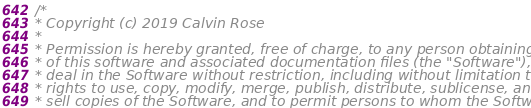<code> <loc_0><loc_0><loc_500><loc_500><_C_>/*
* Copyright (c) 2019 Calvin Rose
*
* Permission is hereby granted, free of charge, to any person obtaining a copy
* of this software and associated documentation files (the "Software"), to
* deal in the Software without restriction, including without limitation the
* rights to use, copy, modify, merge, publish, distribute, sublicense, and/or
* sell copies of the Software, and to permit persons to whom the Software is</code> 